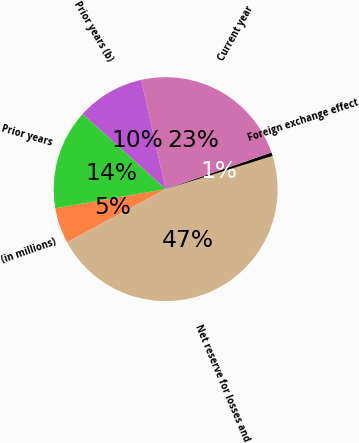Convert chart. <chart><loc_0><loc_0><loc_500><loc_500><pie_chart><fcel>(in millions)<fcel>Net reserve for losses and<fcel>Foreign exchange effect<fcel>Current year<fcel>Prior years (b)<fcel>Prior years<nl><fcel>5.15%<fcel>46.91%<fcel>0.51%<fcel>23.2%<fcel>9.79%<fcel>14.43%<nl></chart> 